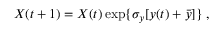Convert formula to latex. <formula><loc_0><loc_0><loc_500><loc_500>X ( t + 1 ) = X ( t ) \exp \{ \sigma _ { y } [ y ( t ) + \bar { y } ] \} \, ,</formula> 